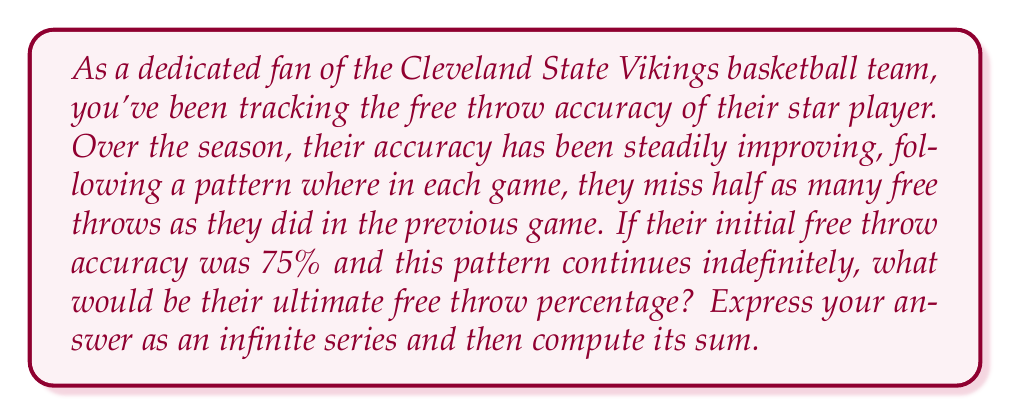Solve this math problem. Let's approach this step-by-step:

1) First, we need to express the player's accuracy as an infinite series. Let's start with the initial accuracy of 75% = 0.75.

2) In each subsequent game, the player misses half as many shots as before. This means they're adding half of what they were missing before to their accuracy.

3) Initially, they were missing 25% = 0.25 of their shots.

4) So, the series would look like this:

   $$ 0.75 + 0.25 \cdot \frac{1}{2} + 0.25 \cdot \frac{1}{4} + 0.25 \cdot \frac{1}{8} + ... $$

5) This can be rewritten as:

   $$ 0.75 + 0.25 \cdot (0.5 + 0.25 + 0.125 + ...) $$

6) The part in parentheses is a geometric series with first term $a = 0.5$ and common ratio $r = 0.5$.

7) For an infinite geometric series with $|r| < 1$, the sum is given by $\frac{a}{1-r}$.

8) In this case, $\frac{0.5}{1-0.5} = \frac{0.5}{0.5} = 1$

9) So our series becomes:

   $$ 0.75 + 0.25 \cdot 1 = 0.75 + 0.25 = 1 $$

Therefore, if this pattern continues indefinitely, the player's free throw accuracy would approach 100%.
Answer: $$ 0.75 + 0.25 \cdot \sum_{n=1}^{\infty} (\frac{1}{2})^n = 1 $$
The ultimate free throw percentage would be 100%. 